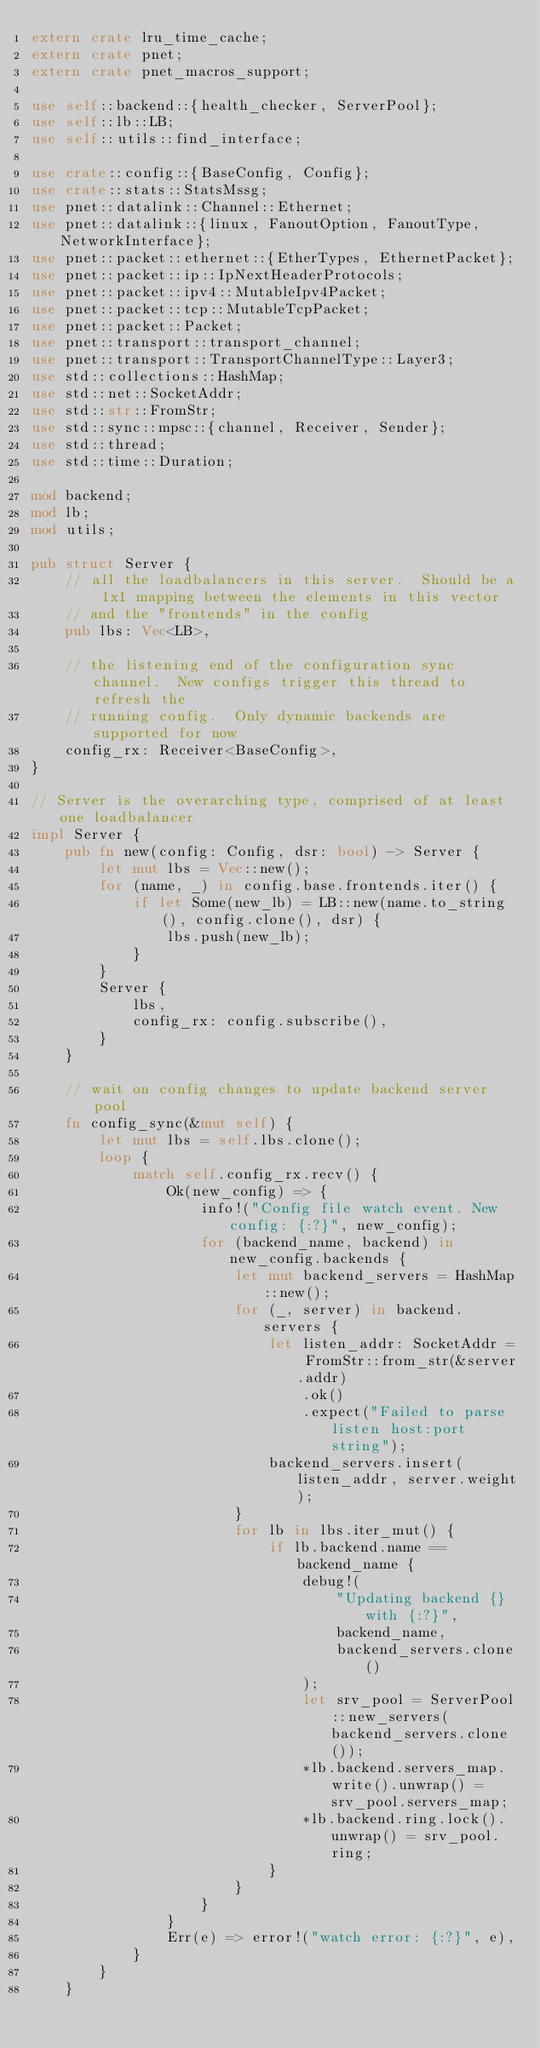Convert code to text. <code><loc_0><loc_0><loc_500><loc_500><_Rust_>extern crate lru_time_cache;
extern crate pnet;
extern crate pnet_macros_support;

use self::backend::{health_checker, ServerPool};
use self::lb::LB;
use self::utils::find_interface;

use crate::config::{BaseConfig, Config};
use crate::stats::StatsMssg;
use pnet::datalink::Channel::Ethernet;
use pnet::datalink::{linux, FanoutOption, FanoutType, NetworkInterface};
use pnet::packet::ethernet::{EtherTypes, EthernetPacket};
use pnet::packet::ip::IpNextHeaderProtocols;
use pnet::packet::ipv4::MutableIpv4Packet;
use pnet::packet::tcp::MutableTcpPacket;
use pnet::packet::Packet;
use pnet::transport::transport_channel;
use pnet::transport::TransportChannelType::Layer3;
use std::collections::HashMap;
use std::net::SocketAddr;
use std::str::FromStr;
use std::sync::mpsc::{channel, Receiver, Sender};
use std::thread;
use std::time::Duration;

mod backend;
mod lb;
mod utils;

pub struct Server {
    // all the loadbalancers in this server.  Should be a 1x1 mapping between the elements in this vector
    // and the "frontends" in the config
    pub lbs: Vec<LB>,

    // the listening end of the configuration sync channel.  New configs trigger this thread to refresh the
    // running config.  Only dynamic backends are supported for now
    config_rx: Receiver<BaseConfig>,
}

// Server is the overarching type, comprised of at least one loadbalancer
impl Server {
    pub fn new(config: Config, dsr: bool) -> Server {
        let mut lbs = Vec::new();
        for (name, _) in config.base.frontends.iter() {
            if let Some(new_lb) = LB::new(name.to_string(), config.clone(), dsr) {
                lbs.push(new_lb);
            }
        }
        Server {
            lbs,
            config_rx: config.subscribe(),
        }
    }

    // wait on config changes to update backend server pool
    fn config_sync(&mut self) {
        let mut lbs = self.lbs.clone();
        loop {
            match self.config_rx.recv() {
                Ok(new_config) => {
                    info!("Config file watch event. New config: {:?}", new_config);
                    for (backend_name, backend) in new_config.backends {
                        let mut backend_servers = HashMap::new();
                        for (_, server) in backend.servers {
                            let listen_addr: SocketAddr = FromStr::from_str(&server.addr)
                                .ok()
                                .expect("Failed to parse listen host:port string");
                            backend_servers.insert(listen_addr, server.weight);
                        }
                        for lb in lbs.iter_mut() {
                            if lb.backend.name == backend_name {
                                debug!(
                                    "Updating backend {} with {:?}",
                                    backend_name,
                                    backend_servers.clone()
                                );
                                let srv_pool = ServerPool::new_servers(backend_servers.clone());
                                *lb.backend.servers_map.write().unwrap() = srv_pool.servers_map;
                                *lb.backend.ring.lock().unwrap() = srv_pool.ring;
                            }
                        }
                    }
                }
                Err(e) => error!("watch error: {:?}", e),
            }
        }
    }
</code> 